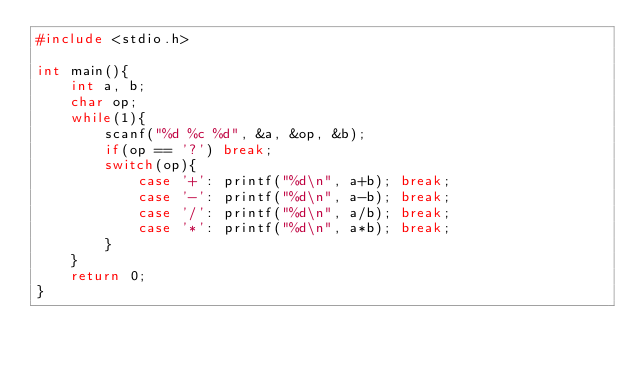<code> <loc_0><loc_0><loc_500><loc_500><_C_>#include <stdio.h>

int main(){
    int a, b;
    char op;
    while(1){
        scanf("%d %c %d", &a, &op, &b);
        if(op == '?') break;
        switch(op){
            case '+': printf("%d\n", a+b); break;
            case '-': printf("%d\n", a-b); break;
            case '/': printf("%d\n", a/b); break;
            case '*': printf("%d\n", a*b); break;
        }
    }
    return 0;
}</code> 